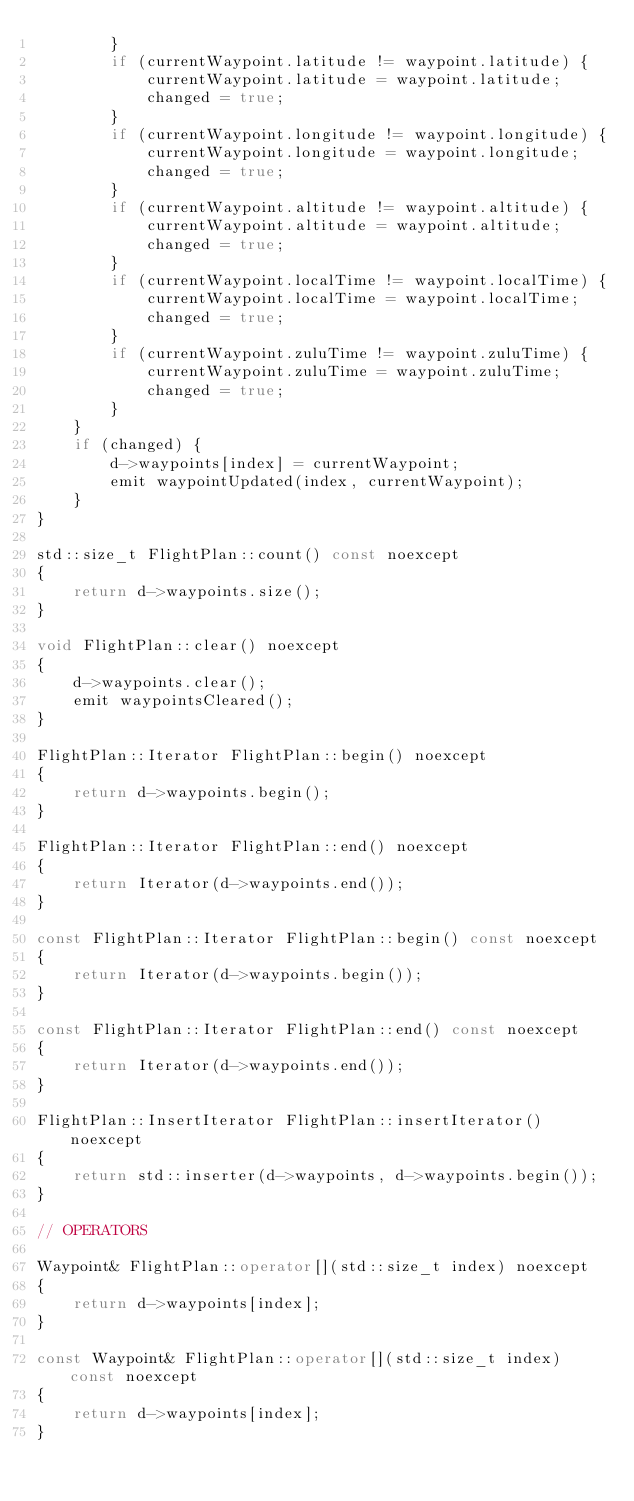<code> <loc_0><loc_0><loc_500><loc_500><_C++_>        }
        if (currentWaypoint.latitude != waypoint.latitude) {
            currentWaypoint.latitude = waypoint.latitude;
            changed = true;
        }
        if (currentWaypoint.longitude != waypoint.longitude) {
            currentWaypoint.longitude = waypoint.longitude;
            changed = true;
        }
        if (currentWaypoint.altitude != waypoint.altitude) {
            currentWaypoint.altitude = waypoint.altitude;
            changed = true;
        }
        if (currentWaypoint.localTime != waypoint.localTime) {
            currentWaypoint.localTime = waypoint.localTime;
            changed = true;
        }
        if (currentWaypoint.zuluTime != waypoint.zuluTime) {
            currentWaypoint.zuluTime = waypoint.zuluTime;
            changed = true;
        }
    }
    if (changed) {
        d->waypoints[index] = currentWaypoint;
        emit waypointUpdated(index, currentWaypoint);
    }
}

std::size_t FlightPlan::count() const noexcept
{
    return d->waypoints.size();
}

void FlightPlan::clear() noexcept
{
    d->waypoints.clear();
    emit waypointsCleared();
}

FlightPlan::Iterator FlightPlan::begin() noexcept
{
    return d->waypoints.begin();
}

FlightPlan::Iterator FlightPlan::end() noexcept
{
    return Iterator(d->waypoints.end());
}

const FlightPlan::Iterator FlightPlan::begin() const noexcept
{
    return Iterator(d->waypoints.begin());
}

const FlightPlan::Iterator FlightPlan::end() const noexcept
{
    return Iterator(d->waypoints.end());
}

FlightPlan::InsertIterator FlightPlan::insertIterator() noexcept
{
    return std::inserter(d->waypoints, d->waypoints.begin());
}

// OPERATORS

Waypoint& FlightPlan::operator[](std::size_t index) noexcept
{
    return d->waypoints[index];
}

const Waypoint& FlightPlan::operator[](std::size_t index) const noexcept
{
    return d->waypoints[index];
}
</code> 